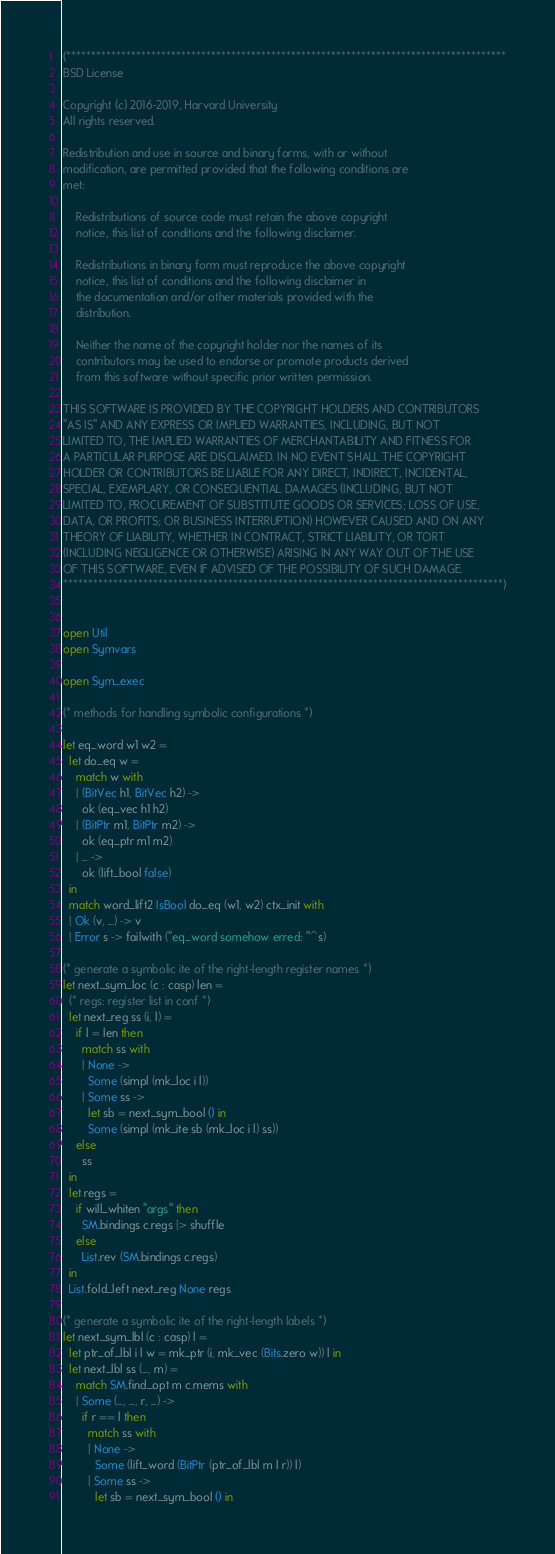<code> <loc_0><loc_0><loc_500><loc_500><_OCaml_>(****************************************************************************************
BSD License

Copyright (c) 2016-2019, Harvard University
All rights reserved.

Redistribution and use in source and binary forms, with or without
modification, are permitted provided that the following conditions are
met:

    Redistributions of source code must retain the above copyright
    notice, this list of conditions and the following disclaimer.

    Redistributions in binary form must reproduce the above copyright
    notice, this list of conditions and the following disclaimer in
    the documentation and/or other materials provided with the
    distribution.

    Neither the name of the copyright holder nor the names of its
    contributors may be used to endorse or promote products derived
    from this software without specific prior written permission.

THIS SOFTWARE IS PROVIDED BY THE COPYRIGHT HOLDERS AND CONTRIBUTORS
"AS IS" AND ANY EXPRESS OR IMPLIED WARRANTIES, INCLUDING, BUT NOT
LIMITED TO, THE IMPLIED WARRANTIES OF MERCHANTABILITY AND FITNESS FOR
A PARTICULAR PURPOSE ARE DISCLAIMED. IN NO EVENT SHALL THE COPYRIGHT
HOLDER OR CONTRIBUTORS BE LIABLE FOR ANY DIRECT, INDIRECT, INCIDENTAL,
SPECIAL, EXEMPLARY, OR CONSEQUENTIAL DAMAGES (INCLUDING, BUT NOT
LIMITED TO, PROCUREMENT OF SUBSTITUTE GOODS OR SERVICES; LOSS OF USE,
DATA, OR PROFITS; OR BUSINESS INTERRUPTION) HOWEVER CAUSED AND ON ANY
THEORY OF LIABILITY, WHETHER IN CONTRACT, STRICT LIABILITY, OR TORT
(INCLUDING NEGLIGENCE OR OTHERWISE) ARISING IN ANY WAY OUT OF THE USE
OF THIS SOFTWARE, EVEN IF ADVISED OF THE POSSIBILITY OF SUCH DAMAGE.
****************************************************************************************)


open Util
open Symvars

open Sym_exec

(* methods for handling symbolic configurations *)

let eq_word w1 w2 =
  let do_eq w =
    match w with
    | (BitVec h1, BitVec h2) ->
      ok (eq_vec h1 h2)
    | (BitPtr m1, BitPtr m2) ->
      ok (eq_ptr m1 m2)
    | _ ->
      ok (lift_bool false)
  in
  match word_lift2 IsBool do_eq (w1, w2) ctx_init with
  | Ok (v, _) -> v
  | Error s -> failwith ("eq_word somehow erred: "^s)

(* generate a symbolic ite of the right-length register names *)
let next_sym_loc (c : casp) len =
  (* regs: register list in conf *)
  let next_reg ss (i, l) =
    if l = len then
      match ss with
      | None ->
        Some (simpl (mk_loc i l))
      | Some ss ->
        let sb = next_sym_bool () in
        Some (simpl (mk_ite sb (mk_loc i l) ss))
    else
      ss
  in
  let regs =
    if will_whiten "args" then
      SM.bindings c.regs |> shuffle
    else
      List.rev (SM.bindings c.regs)
  in
  List.fold_left next_reg None regs

(* generate a symbolic ite of the right-length labels *)
let next_sym_lbl (c : casp) l =
  let ptr_of_lbl i l w = mk_ptr (i, mk_vec (Bits.zero w)) l in
  let next_lbl ss (_, m) =
    match SM.find_opt m c.mems with
    | Some (_, _, r, _) ->
      if r == l then
        match ss with
        | None ->
          Some (lift_word (BitPtr (ptr_of_lbl m l r)) l)
        | Some ss ->
          let sb = next_sym_bool () in</code> 